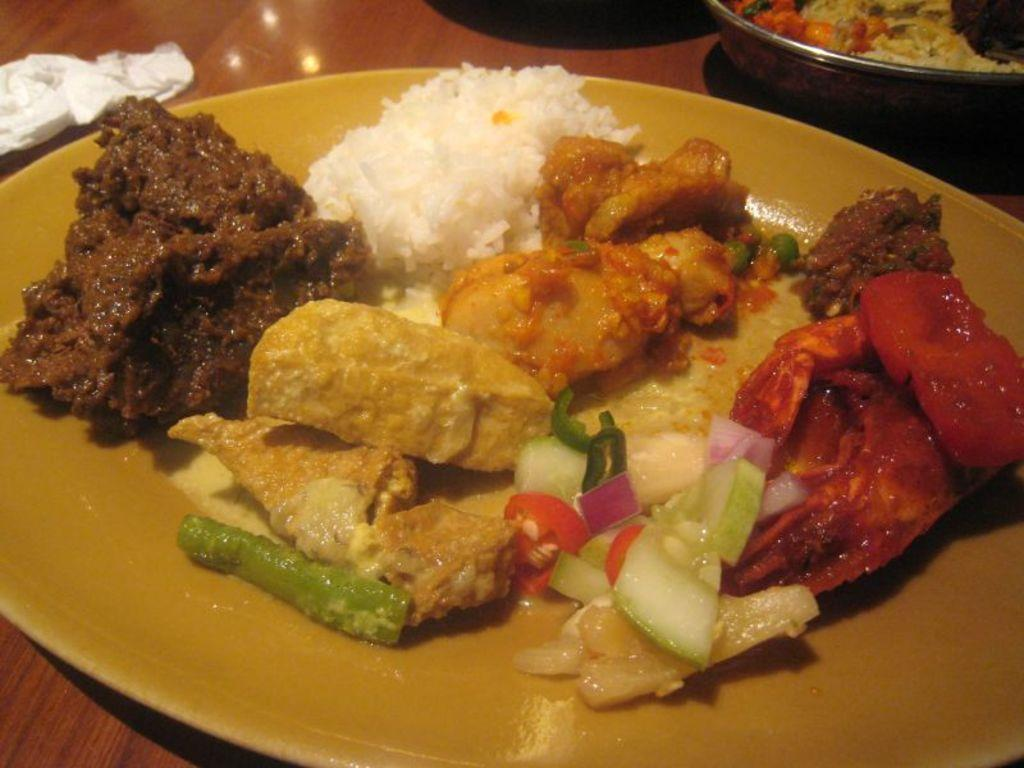What is on the table in the image? There is a plate on the table in the image. What is on the plate? There is a food item visible on the plate. What else can be seen on the table? There is a bowl containing a food item in the image. What song is being sung by the food item on the plate? There is no indication in the image that the food item is singing a song. 